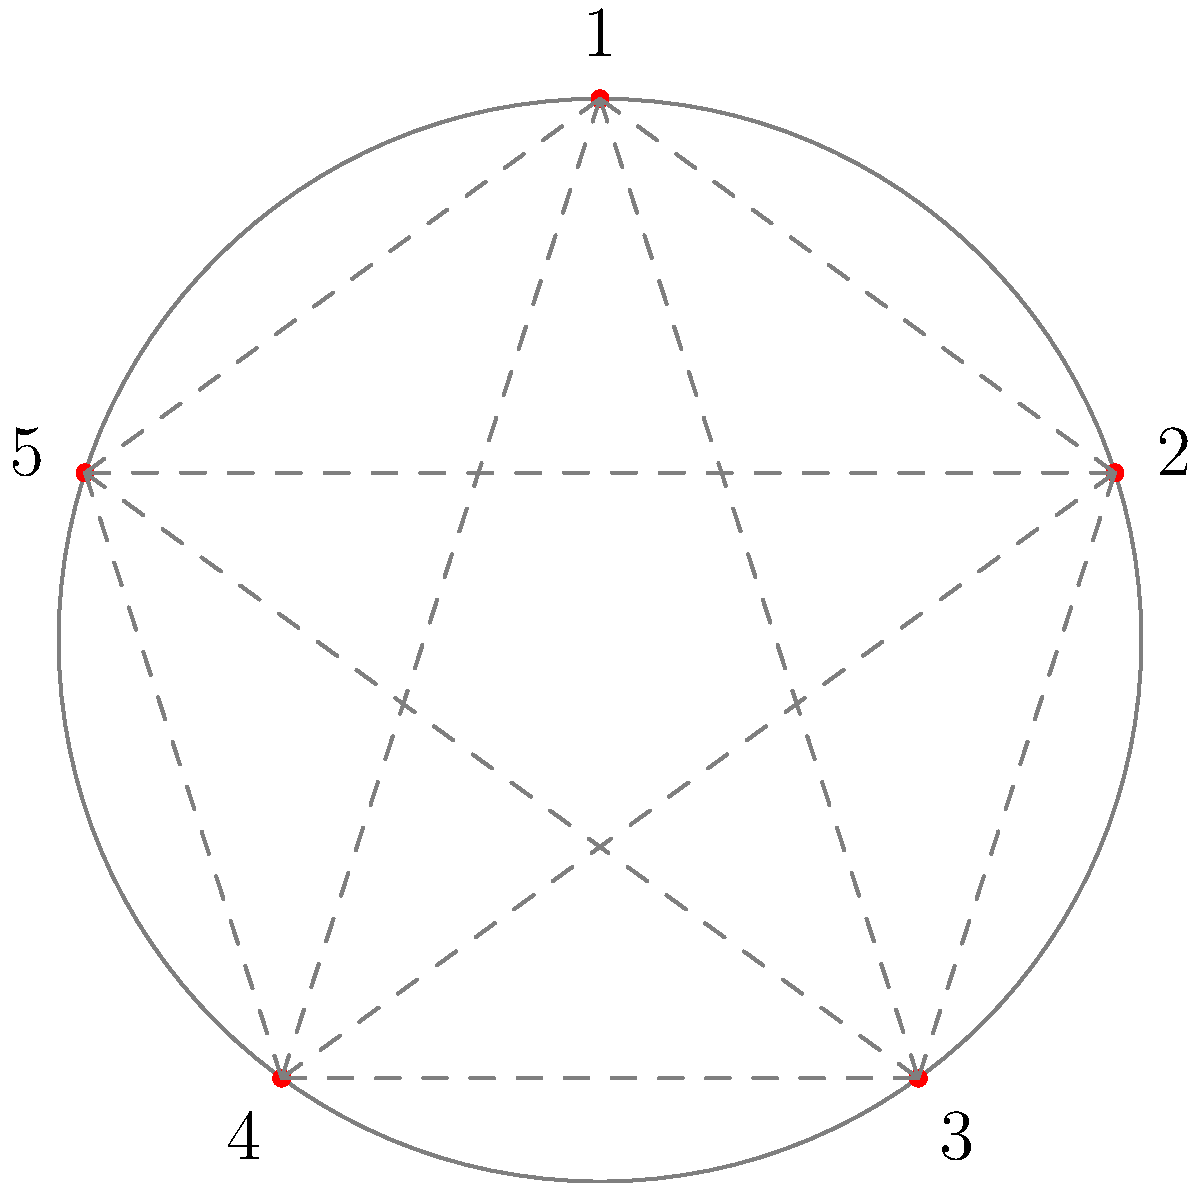In a circular stadium, five radio commentators (numbered 1 to 5) need to be seated such that no two adjacent commentators can hear each other to avoid interference. How many different seating arrangements are possible? Let's approach this step-by-step:

1) First, we need to recognize that this problem is equivalent to finding the number of ways to arrange 5 people in a circle with no two adjacent people being able to hear each other.

2) In graph theory, this is known as finding the number of Hamiltonian cycles in a graph where each node represents a commentator, and edges represent pairs of commentators who can't hear each other.

3) Given the condition, each commentator can't hear the two adjacent commentators. So in the graph, each node is connected to all nodes except its two adjacent ones.

4) For 5 commentators, this forms a pentagon with all diagonals drawn (as shown in the diagram).

5) To count the number of valid arrangements, we can:
   a) Fix the position of one commentator (say, commentator 1).
   b) Count the number of ways to arrange the other 4 commentators.

6) With commentator 1 fixed, we need to arrange 2, 3, 4, and 5 such that no two adjacent numbers in the sequence are adjacent in the original pentagon.

7) The possible arrangements are:
   2-4-1-3-5
   2-5-1-3-4
   3-5-1-4-2
   4-2-1-5-3

8) Therefore, there are 4 possible arrangements.
Answer: 4 